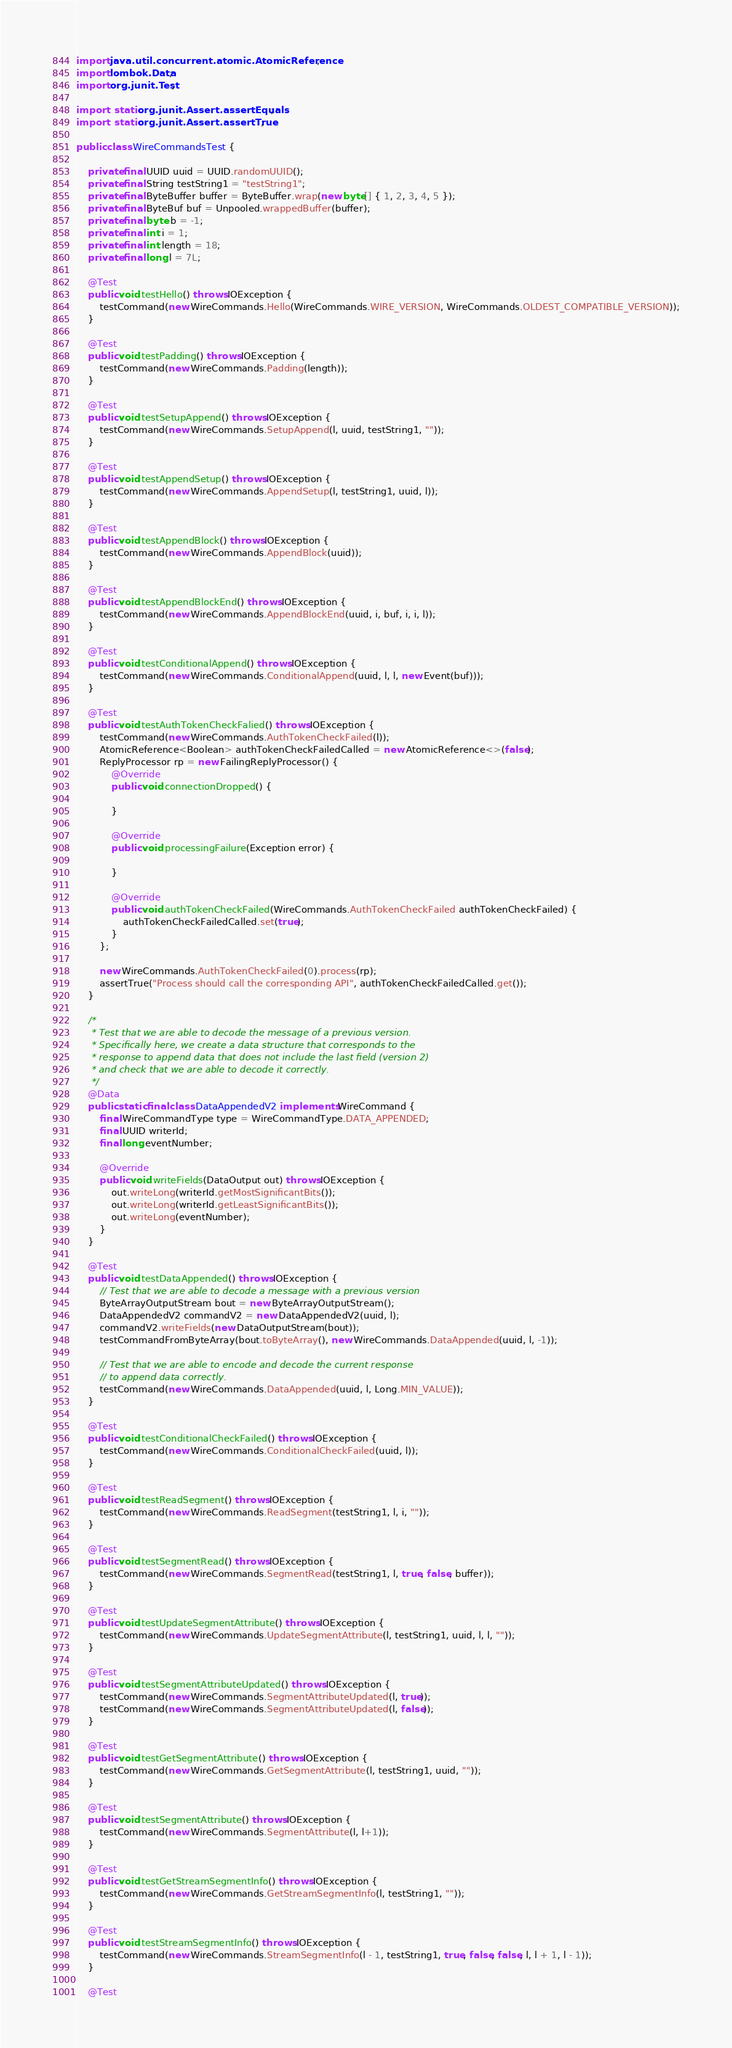<code> <loc_0><loc_0><loc_500><loc_500><_Java_>import java.util.concurrent.atomic.AtomicReference;
import lombok.Data;
import org.junit.Test;

import static org.junit.Assert.assertEquals;
import static org.junit.Assert.assertTrue;

public class WireCommandsTest {

    private final UUID uuid = UUID.randomUUID();
    private final String testString1 = "testString1";
    private final ByteBuffer buffer = ByteBuffer.wrap(new byte[] { 1, 2, 3, 4, 5 });
    private final ByteBuf buf = Unpooled.wrappedBuffer(buffer);
    private final byte b = -1;
    private final int i = 1;
    private final int length = 18;
    private final long l = 7L;

    @Test
    public void testHello() throws IOException {
        testCommand(new WireCommands.Hello(WireCommands.WIRE_VERSION, WireCommands.OLDEST_COMPATIBLE_VERSION));
    }

    @Test
    public void testPadding() throws IOException {
        testCommand(new WireCommands.Padding(length));
    }

    @Test
    public void testSetupAppend() throws IOException {
        testCommand(new WireCommands.SetupAppend(l, uuid, testString1, ""));
    }

    @Test
    public void testAppendSetup() throws IOException {
        testCommand(new WireCommands.AppendSetup(l, testString1, uuid, l));
    }

    @Test
    public void testAppendBlock() throws IOException {
        testCommand(new WireCommands.AppendBlock(uuid));
    }

    @Test
    public void testAppendBlockEnd() throws IOException {
        testCommand(new WireCommands.AppendBlockEnd(uuid, i, buf, i, i, l));
    }

    @Test
    public void testConditionalAppend() throws IOException {
        testCommand(new WireCommands.ConditionalAppend(uuid, l, l, new Event(buf)));
    }

    @Test
    public void testAuthTokenCheckFalied() throws IOException {
        testCommand(new WireCommands.AuthTokenCheckFailed(l));
        AtomicReference<Boolean> authTokenCheckFailedCalled = new AtomicReference<>(false);
        ReplyProcessor rp = new FailingReplyProcessor() {
            @Override
            public void connectionDropped() {

            }

            @Override
            public void processingFailure(Exception error) {

            }

            @Override
            public void authTokenCheckFailed(WireCommands.AuthTokenCheckFailed authTokenCheckFailed) {
                authTokenCheckFailedCalled.set(true);
            }
        };

        new WireCommands.AuthTokenCheckFailed(0).process(rp);
        assertTrue("Process should call the corresponding API", authTokenCheckFailedCalled.get());
    }

    /*
     * Test that we are able to decode the message of a previous version.
     * Specifically here, we create a data structure that corresponds to the
     * response to append data that does not include the last field (version 2)
     * and check that we are able to decode it correctly.
     */
    @Data
    public static final class DataAppendedV2 implements WireCommand {
        final WireCommandType type = WireCommandType.DATA_APPENDED;
        final UUID writerId;
        final long eventNumber;

        @Override
        public void writeFields(DataOutput out) throws IOException {
            out.writeLong(writerId.getMostSignificantBits());
            out.writeLong(writerId.getLeastSignificantBits());
            out.writeLong(eventNumber);
        }
    }

    @Test
    public void testDataAppended() throws IOException {
        // Test that we are able to decode a message with a previous version
        ByteArrayOutputStream bout = new ByteArrayOutputStream();
        DataAppendedV2 commandV2 = new DataAppendedV2(uuid, l);
        commandV2.writeFields(new DataOutputStream(bout));
        testCommandFromByteArray(bout.toByteArray(), new WireCommands.DataAppended(uuid, l, -1));

        // Test that we are able to encode and decode the current response
        // to append data correctly.
        testCommand(new WireCommands.DataAppended(uuid, l, Long.MIN_VALUE));
    }

    @Test
    public void testConditionalCheckFailed() throws IOException {
        testCommand(new WireCommands.ConditionalCheckFailed(uuid, l));
    }

    @Test
    public void testReadSegment() throws IOException {
        testCommand(new WireCommands.ReadSegment(testString1, l, i, ""));
    }

    @Test
    public void testSegmentRead() throws IOException {
        testCommand(new WireCommands.SegmentRead(testString1, l, true, false, buffer));
    }
    
    @Test
    public void testUpdateSegmentAttribute() throws IOException {
        testCommand(new WireCommands.UpdateSegmentAttribute(l, testString1, uuid, l, l, ""));
    }
    
    @Test
    public void testSegmentAttributeUpdated() throws IOException {
        testCommand(new WireCommands.SegmentAttributeUpdated(l, true));
        testCommand(new WireCommands.SegmentAttributeUpdated(l, false));
    }

    @Test
    public void testGetSegmentAttribute() throws IOException {
        testCommand(new WireCommands.GetSegmentAttribute(l, testString1, uuid, ""));
    }
    
    @Test
    public void testSegmentAttribute() throws IOException {
        testCommand(new WireCommands.SegmentAttribute(l, l+1));
    }
    
    @Test
    public void testGetStreamSegmentInfo() throws IOException {
        testCommand(new WireCommands.GetStreamSegmentInfo(l, testString1, ""));
    }

    @Test
    public void testStreamSegmentInfo() throws IOException {
        testCommand(new WireCommands.StreamSegmentInfo(l - 1, testString1, true, false, false, l, l + 1, l - 1));
    }

    @Test</code> 